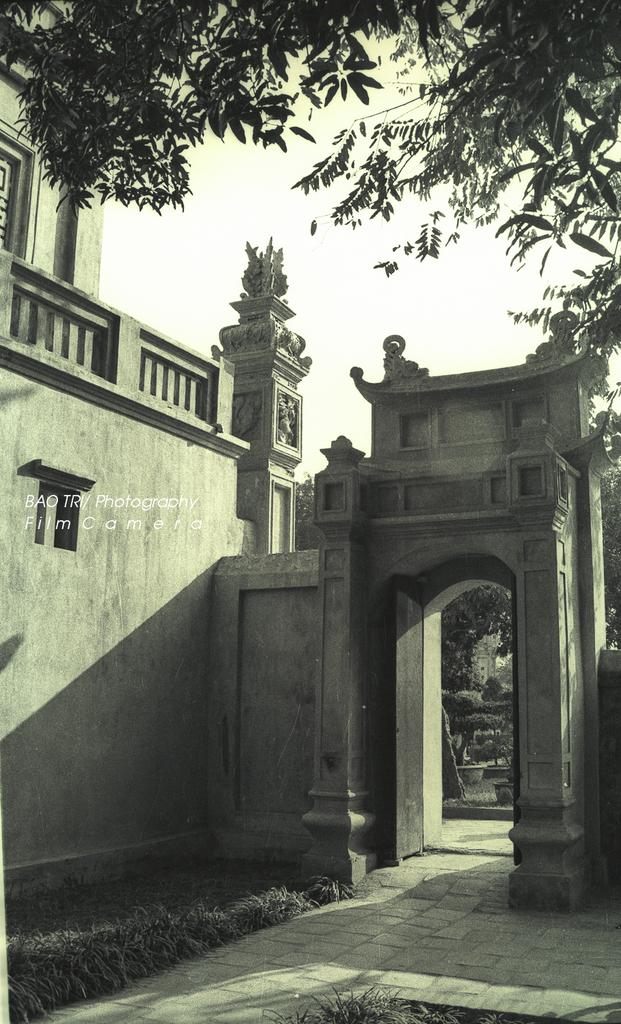What type of structure can be seen in the image? There is a building in the image. What type of vegetation is visible in the image? There is grass visible in the image. Are there any other natural elements present in the image? Yes, there are trees in the image. What can be seen in the background of the image? The sky is visible in the image. What type of attraction is present in the image? There is no attraction mentioned or visible in the image; it features a building, grass, trees, and the sky. 